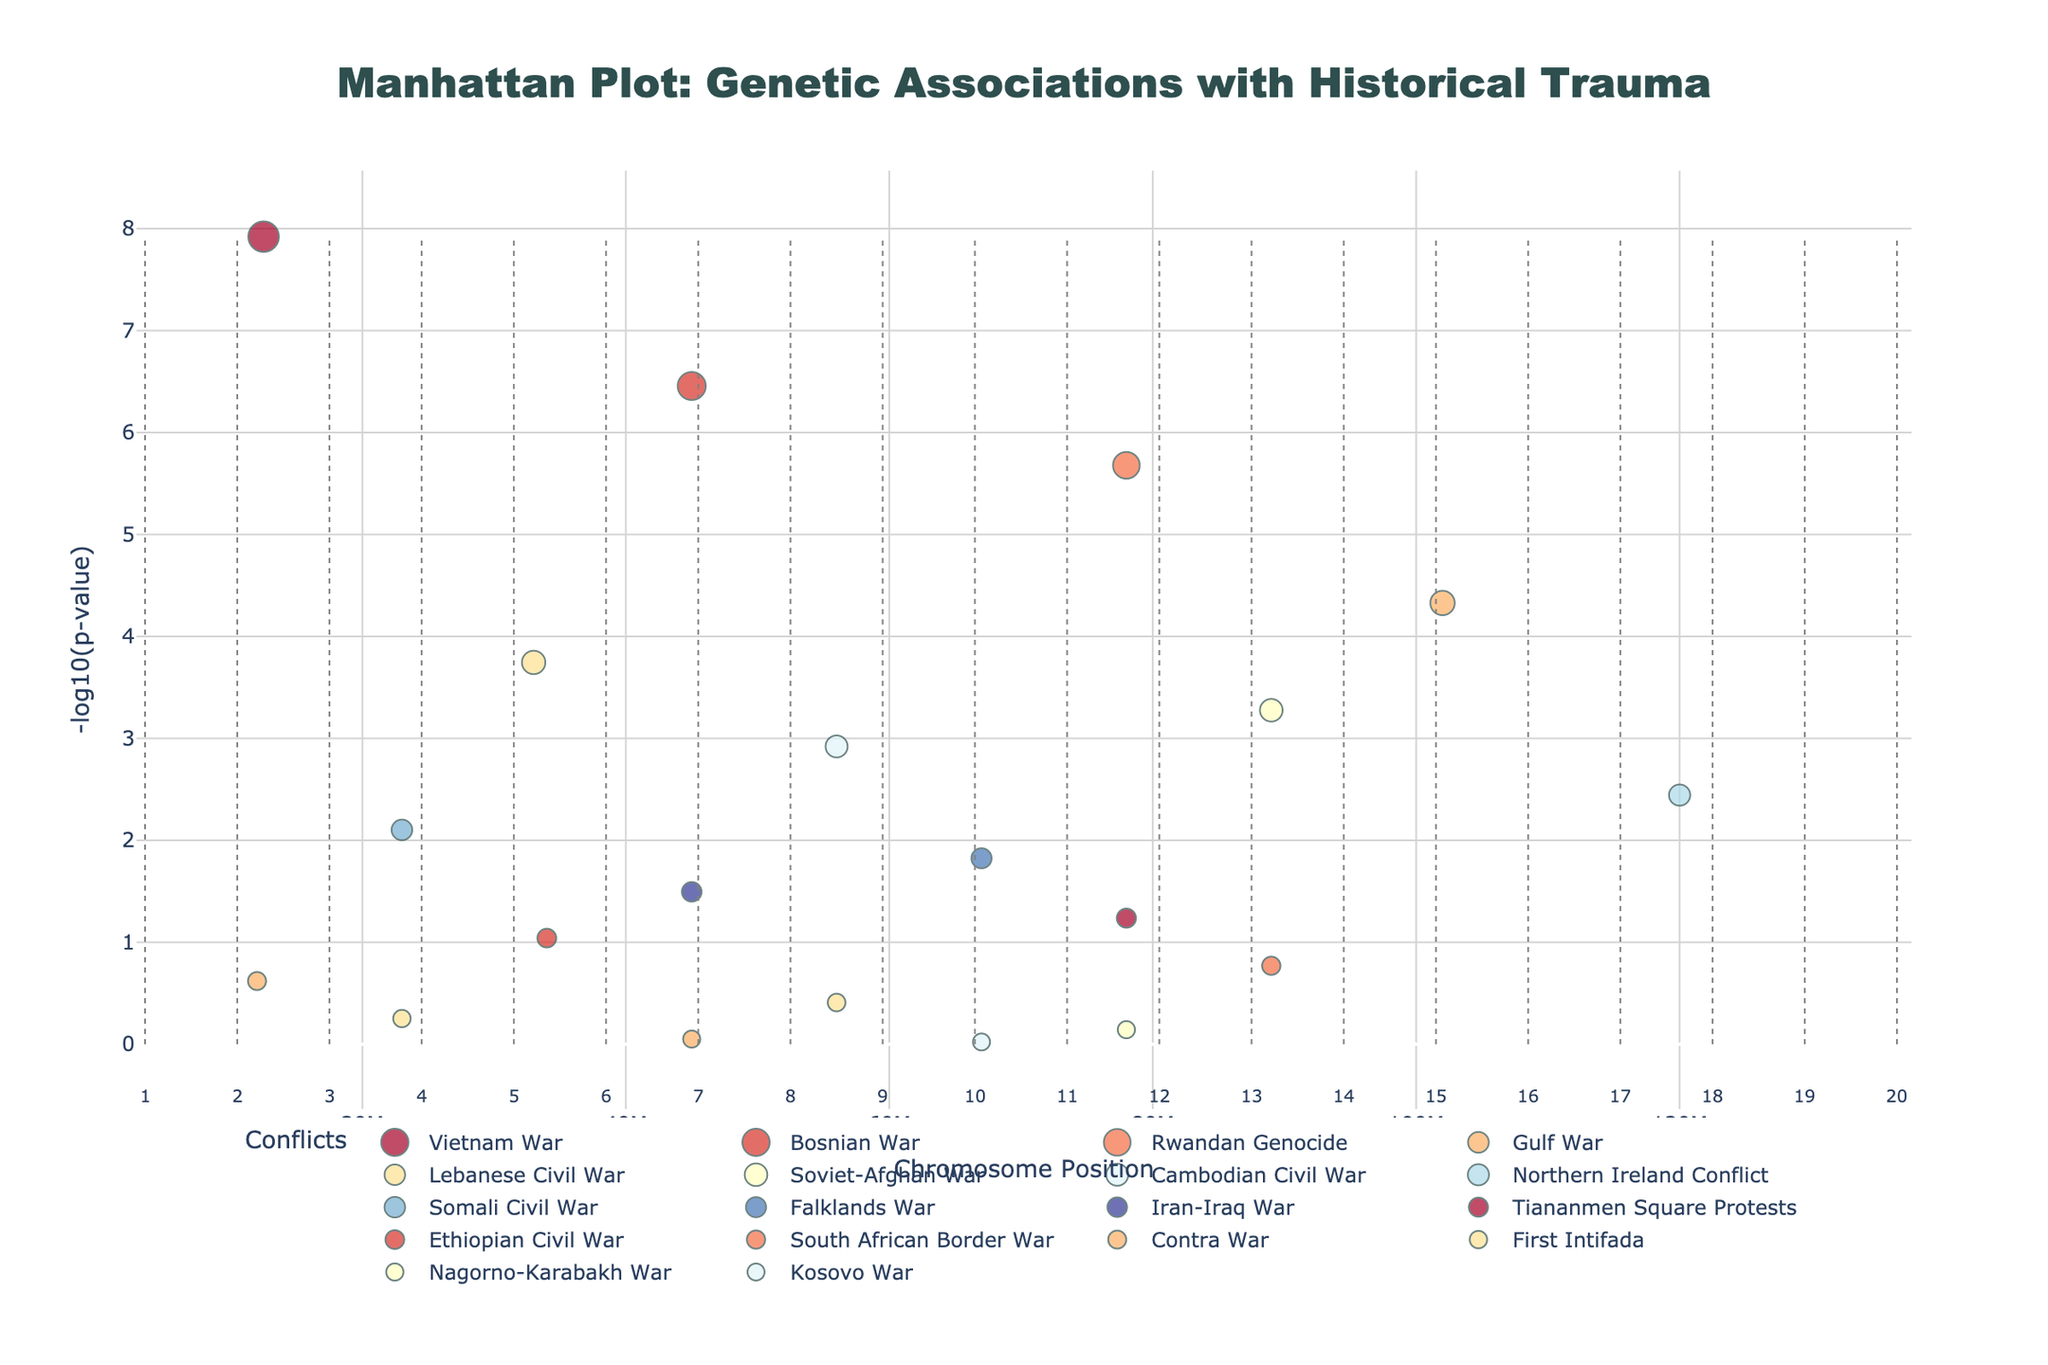What is the title of the plot? The text at the top center of the figure indicates the title of the plot.
Answer: Manhattan Plot: Genetic Associations with Historical Trauma Which gene associated with the Vietnam War has the most significant p-value? To find the most significant p-value, look for the highest -log10(p) value associated with the Vietnam War. The plot shows that FKBP5 on Chromosome 1 associated with the Vietnam War has the highest -log10(p) value.
Answer: FKBP5 How is the y-axis of the plot labeled? The label text at the y-axis indicates its description.
Answer: -log10(p-value) What is the most significant genetic association for the Bosnian War? Check for the highest -log10(p) value among the data points for the Bosnian War. The plot indicates that NR3C1 on Chromosome 2 has the highest value for the Bosnian War.
Answer: NR3C1 List the conflicts associated with Chromosome 4. Observe the plot to see which conflicts correspond to data points on Chromosome 4. The plot shows that the Gulf War is associated with Chromosome 4.
Answer: Gulf War Which conflict is associated with the gene MAOA on Chromosome 6? Locate MAOA on Chromosome 6 and identify the associated conflict. The plot shows that MAOA is linked to the Soviet-Afghan War.
Answer: Soviet-Afghan War How many data points have a -log10(p) value greater than or equal to 5? Count the data points with -log10(p) values greater than or equal to 5. The plot shows 4 points (FKBP5, NR3C1, SLC6A4, BDNF).
Answer: 4 Between the Vietnamese War and the Cambodian Civil War, which conflict has a higher genetic association significance? Compare the highest -log10(p) values for data points related to the Vietnamese War and Cambodian Civil War. FKBP5 associated with the Vietnamese War has a higher -log10(p) value than HTR2A associated with the Cambodian Civil War.
Answer: Vietnamese War Which chromosome has the highest -log10(p) value and which conflict is it associated with? Identify the highest data point on the y-axis and note its chromosome and the associated conflict. The plot shows FKBP5 on Chromosome 1 related to the Vietnamese War has the highest -log10(p) value.
Answer: Chromosome 1, Vietnamese War What is the gene and conflict associated with the data point at Position 33000000 on Chromosome 5? Locate the data point at Position 33000000 on Chromosome 5 and note the gene and conflict. The plot shows the gene is COMT, and the conflict is the Lebanese Civil War.
Answer: COMT, Lebanese Civil War 